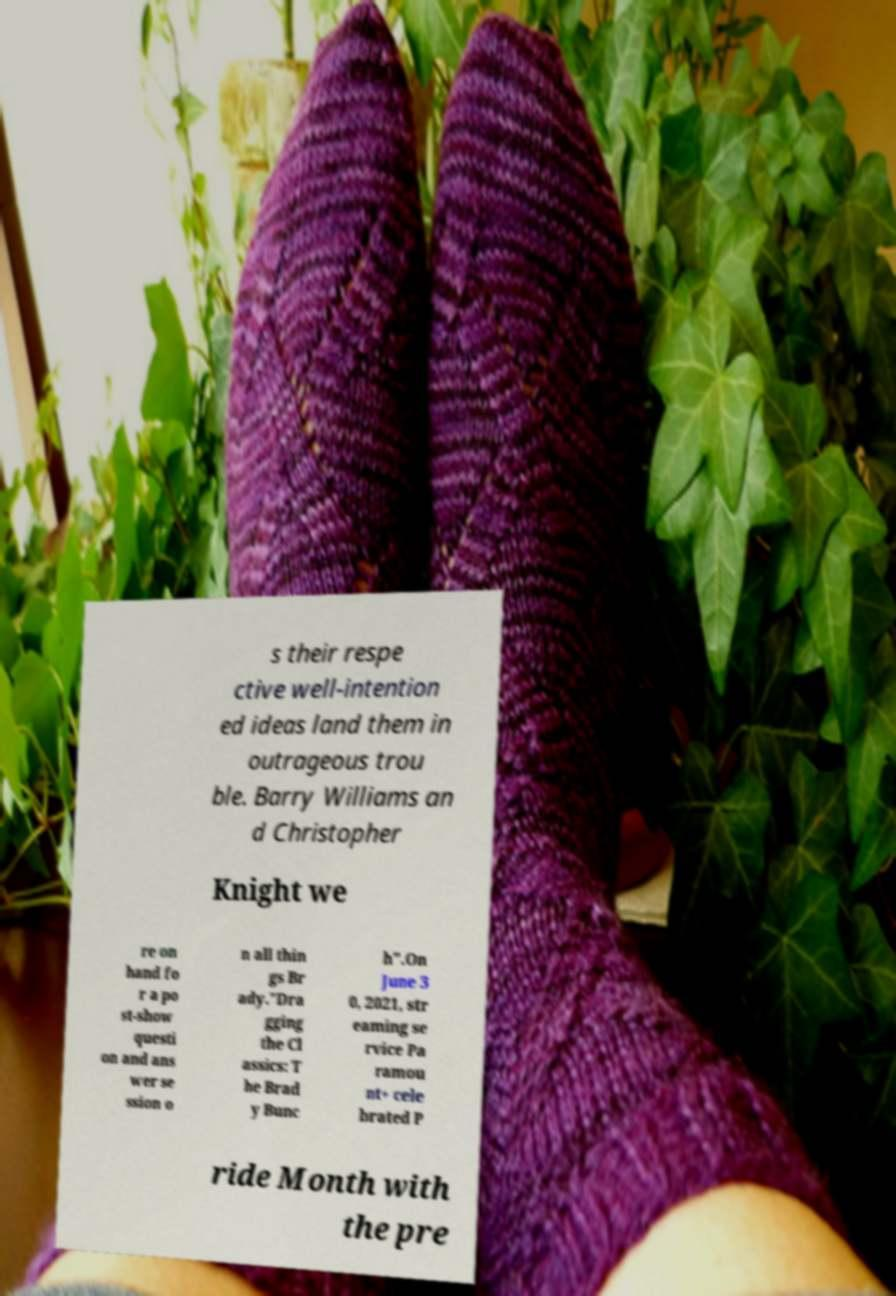Can you accurately transcribe the text from the provided image for me? s their respe ctive well-intention ed ideas land them in outrageous trou ble. Barry Williams an d Christopher Knight we re on hand fo r a po st-show questi on and ans wer se ssion o n all thin gs Br ady."Dra gging the Cl assics: T he Brad y Bunc h".On June 3 0, 2021, str eaming se rvice Pa ramou nt+ cele brated P ride Month with the pre 